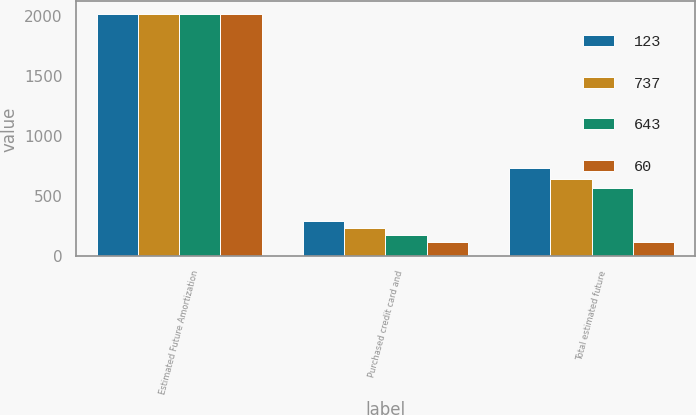<chart> <loc_0><loc_0><loc_500><loc_500><stacked_bar_chart><ecel><fcel>Estimated Future Amortization<fcel>Purchased credit card and<fcel>Total estimated future<nl><fcel>123<fcel>2016<fcel>298<fcel>737<nl><fcel>737<fcel>2017<fcel>237<fcel>643<nl><fcel>643<fcel>2018<fcel>179<fcel>565<nl><fcel>60<fcel>2019<fcel>121<fcel>123<nl></chart> 